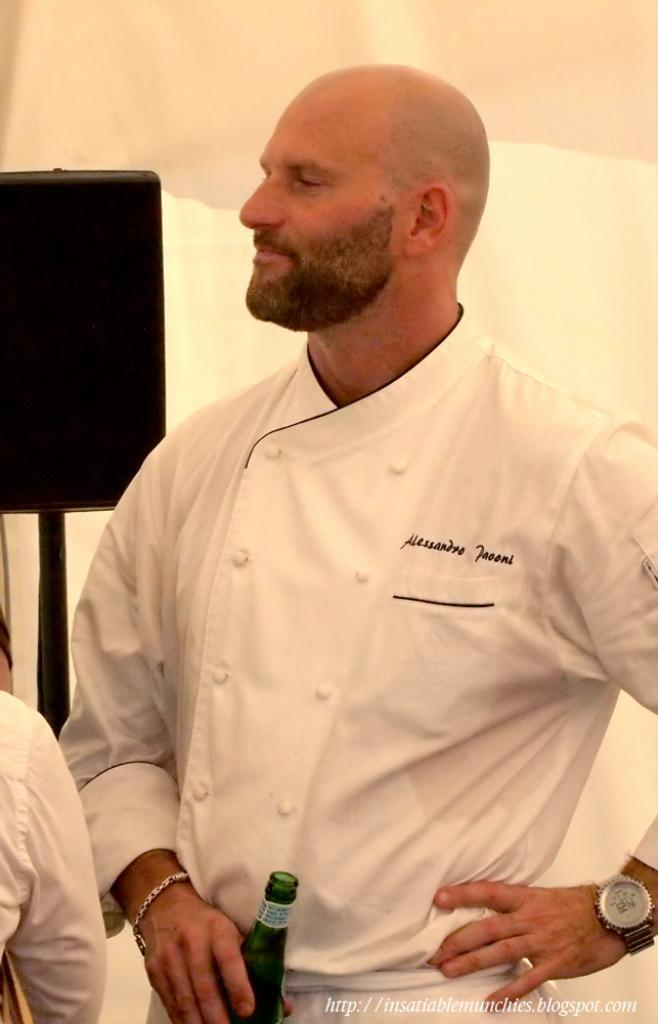<image>
Offer a succinct explanation of the picture presented. A picture of chef Alessandro Paooni holding a bottle. 